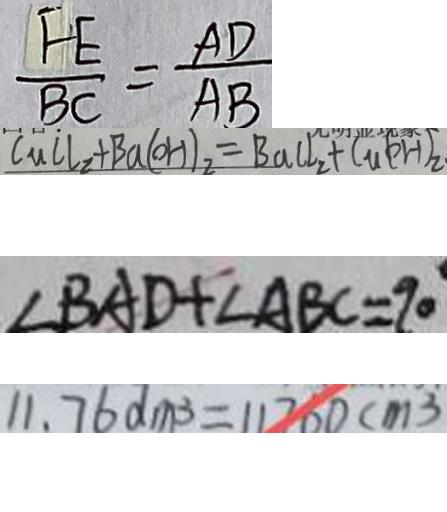Convert formula to latex. <formula><loc_0><loc_0><loc_500><loc_500>\frac { F E } { B C } = \frac { A D } { A B } 
 C u C l _ { 2 } + B a ( O H ) _ { 2 } = B a C l _ { 2 } + C u ( o H ) _ { 2 } 
 \angle B A D + \angle A B C = 9 0 
 1 1 . 7 6 0 d m ^ { 3 } = 1 1 7 6 0 c m ^ { 3 }</formula> 